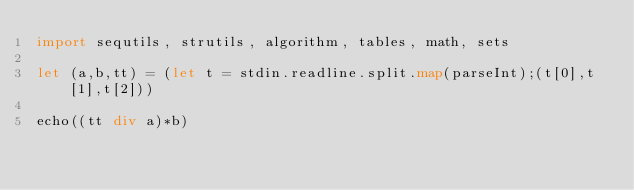Convert code to text. <code><loc_0><loc_0><loc_500><loc_500><_Nim_>import sequtils, strutils, algorithm, tables, math, sets

let (a,b,tt) = (let t = stdin.readline.split.map(parseInt);(t[0],t[1],t[2]))

echo((tt div a)*b)</code> 